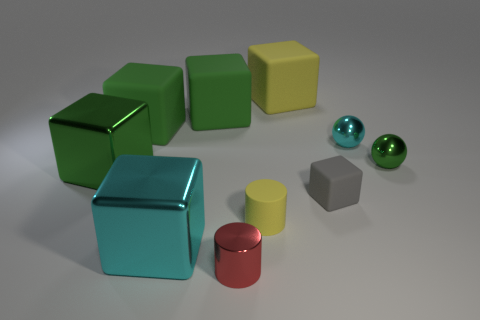There is a shiny block that is behind the cyan metallic cube; is its size the same as the big cyan metal thing?
Make the answer very short. Yes. There is a large metal thing behind the metal block to the right of the green metallic cube; what color is it?
Your answer should be very brief. Green. There is a matte object that is to the right of the big yellow cube; what is its size?
Your answer should be compact. Small. How many green blocks have the same material as the gray thing?
Provide a succinct answer. 2. There is a green object right of the small red metal object; is its shape the same as the large cyan thing?
Ensure brevity in your answer.  No. What is the shape of the tiny rubber thing on the right side of the yellow rubber cube?
Your answer should be very brief. Cube. What size is the rubber thing that is the same color as the small rubber cylinder?
Keep it short and to the point. Large. What is the material of the small cyan ball?
Provide a succinct answer. Metal. The metal object that is the same size as the cyan metal cube is what color?
Your answer should be very brief. Green. What is the shape of the large matte object that is the same color as the rubber cylinder?
Ensure brevity in your answer.  Cube. 